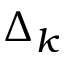Convert formula to latex. <formula><loc_0><loc_0><loc_500><loc_500>\Delta _ { k }</formula> 